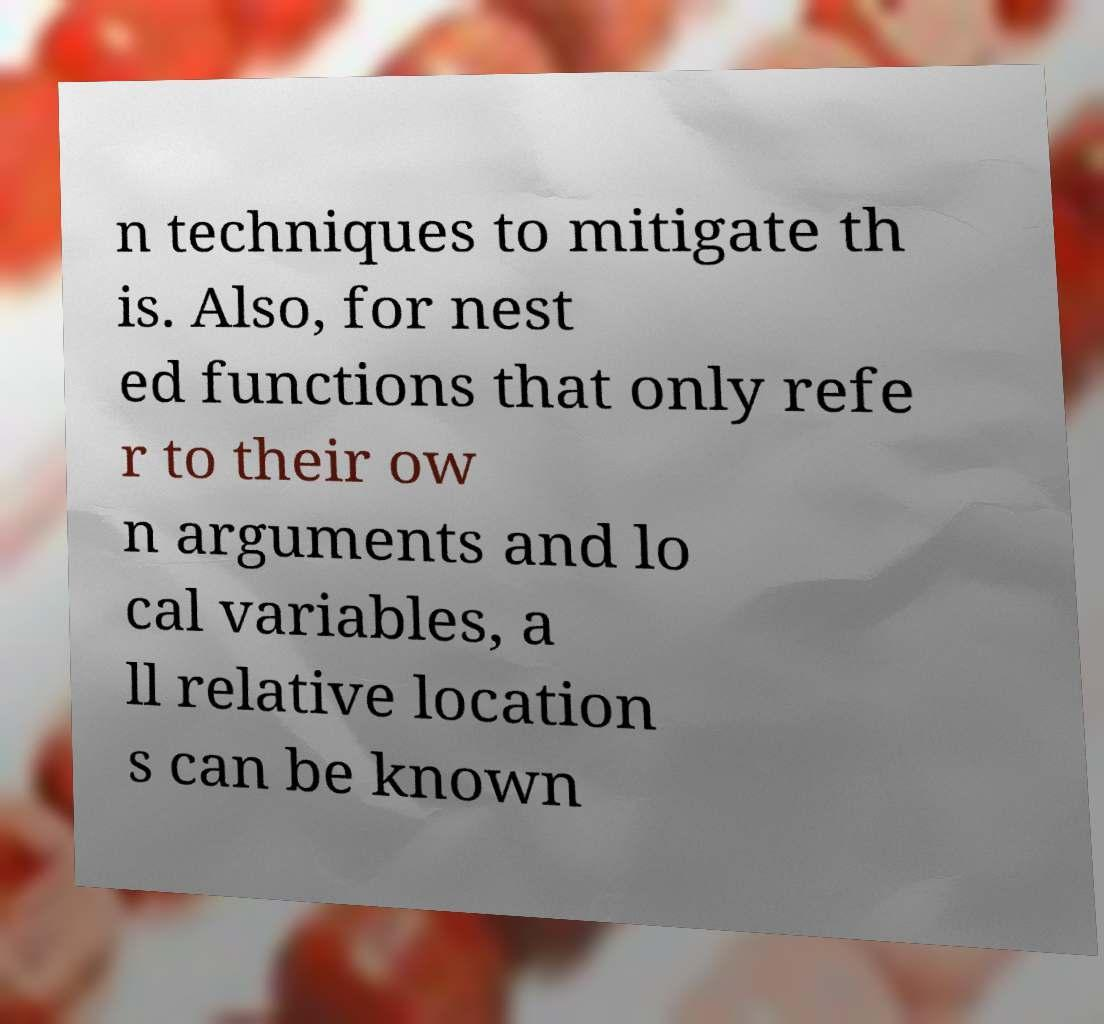Please read and relay the text visible in this image. What does it say? n techniques to mitigate th is. Also, for nest ed functions that only refe r to their ow n arguments and lo cal variables, a ll relative location s can be known 